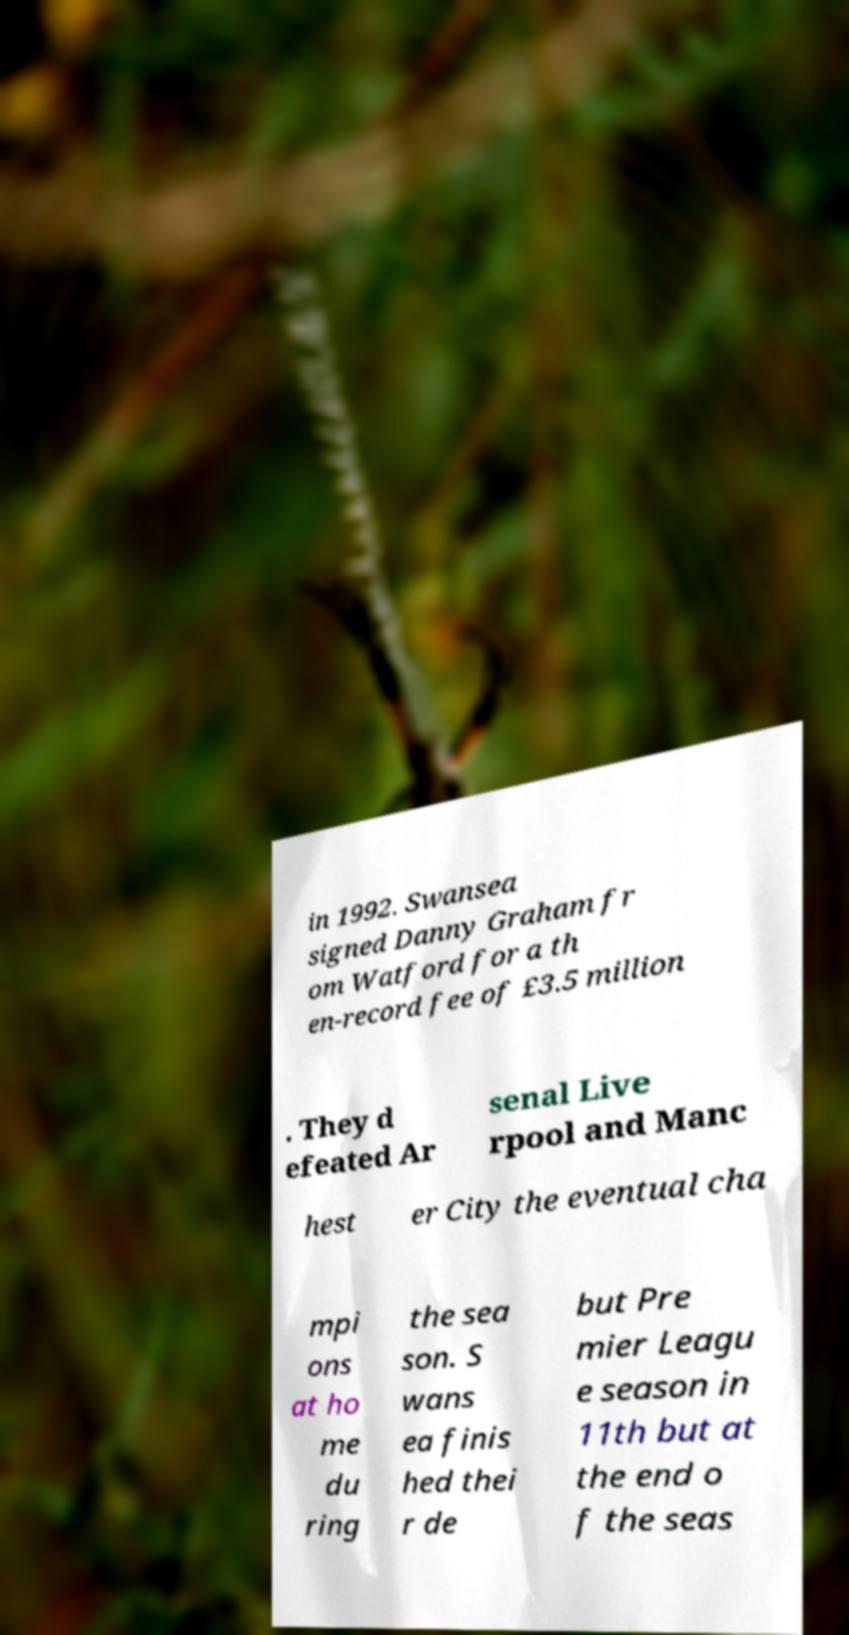There's text embedded in this image that I need extracted. Can you transcribe it verbatim? in 1992. Swansea signed Danny Graham fr om Watford for a th en-record fee of £3.5 million . They d efeated Ar senal Live rpool and Manc hest er City the eventual cha mpi ons at ho me du ring the sea son. S wans ea finis hed thei r de but Pre mier Leagu e season in 11th but at the end o f the seas 